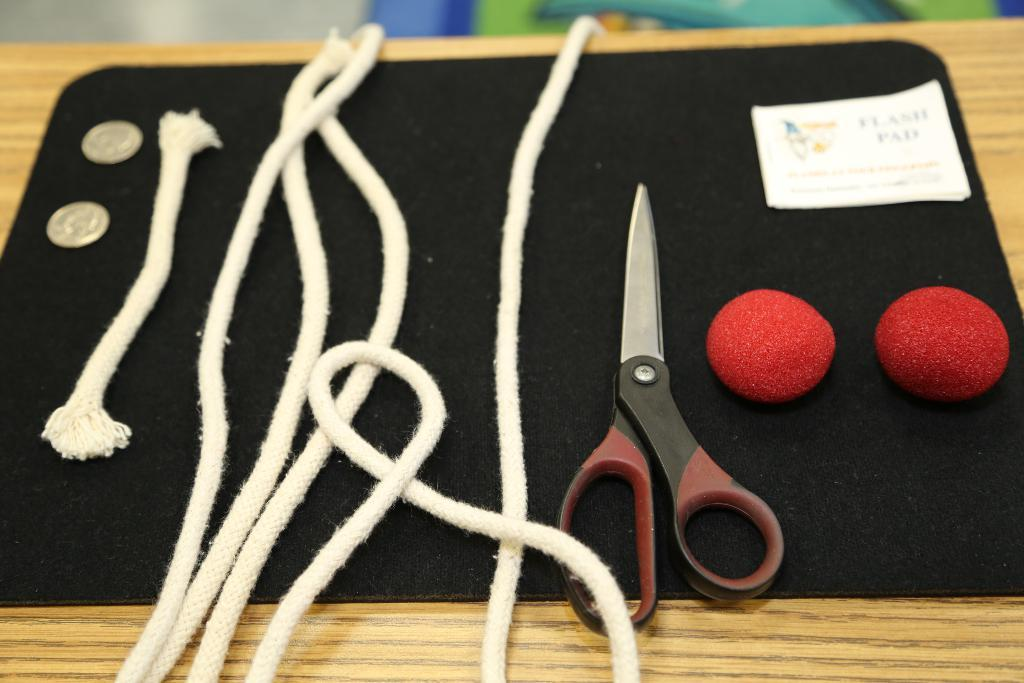What material is the table made of in the image? The table is made of wood. What is placed on the table in the image? There is a black color mat on the table. What can be seen on the mat? There are two coins, threads, scissors, a small paper, and two small red colored balls on the mat. What type of sheet is covering the table in the image? There is no sheet covering the table in the image; it is a wooden table with a black color mat on it. What is the temper of the person who placed the objects on the mat? The image does not provide any information about the temper of the person who placed the objects on the mat. 